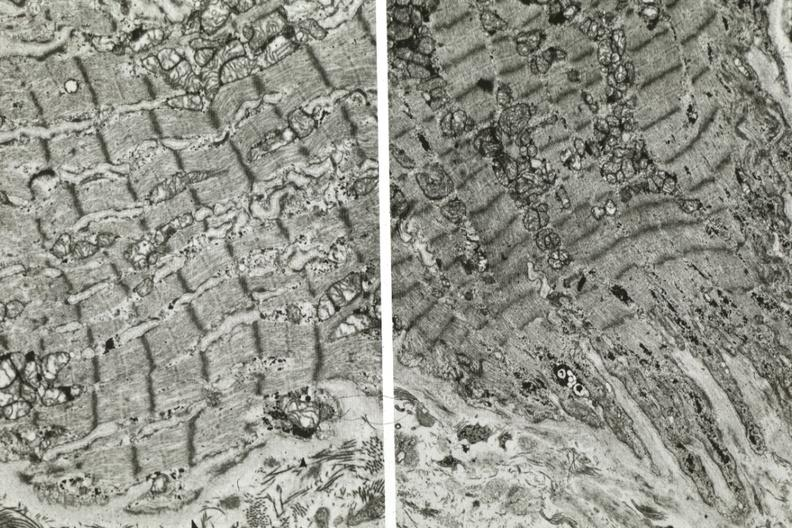does electron micrographs demonstrating fiber not connect with another fiber other frame shows dilated sarcoplasmic reticulum?
Answer the question using a single word or phrase. Yes 